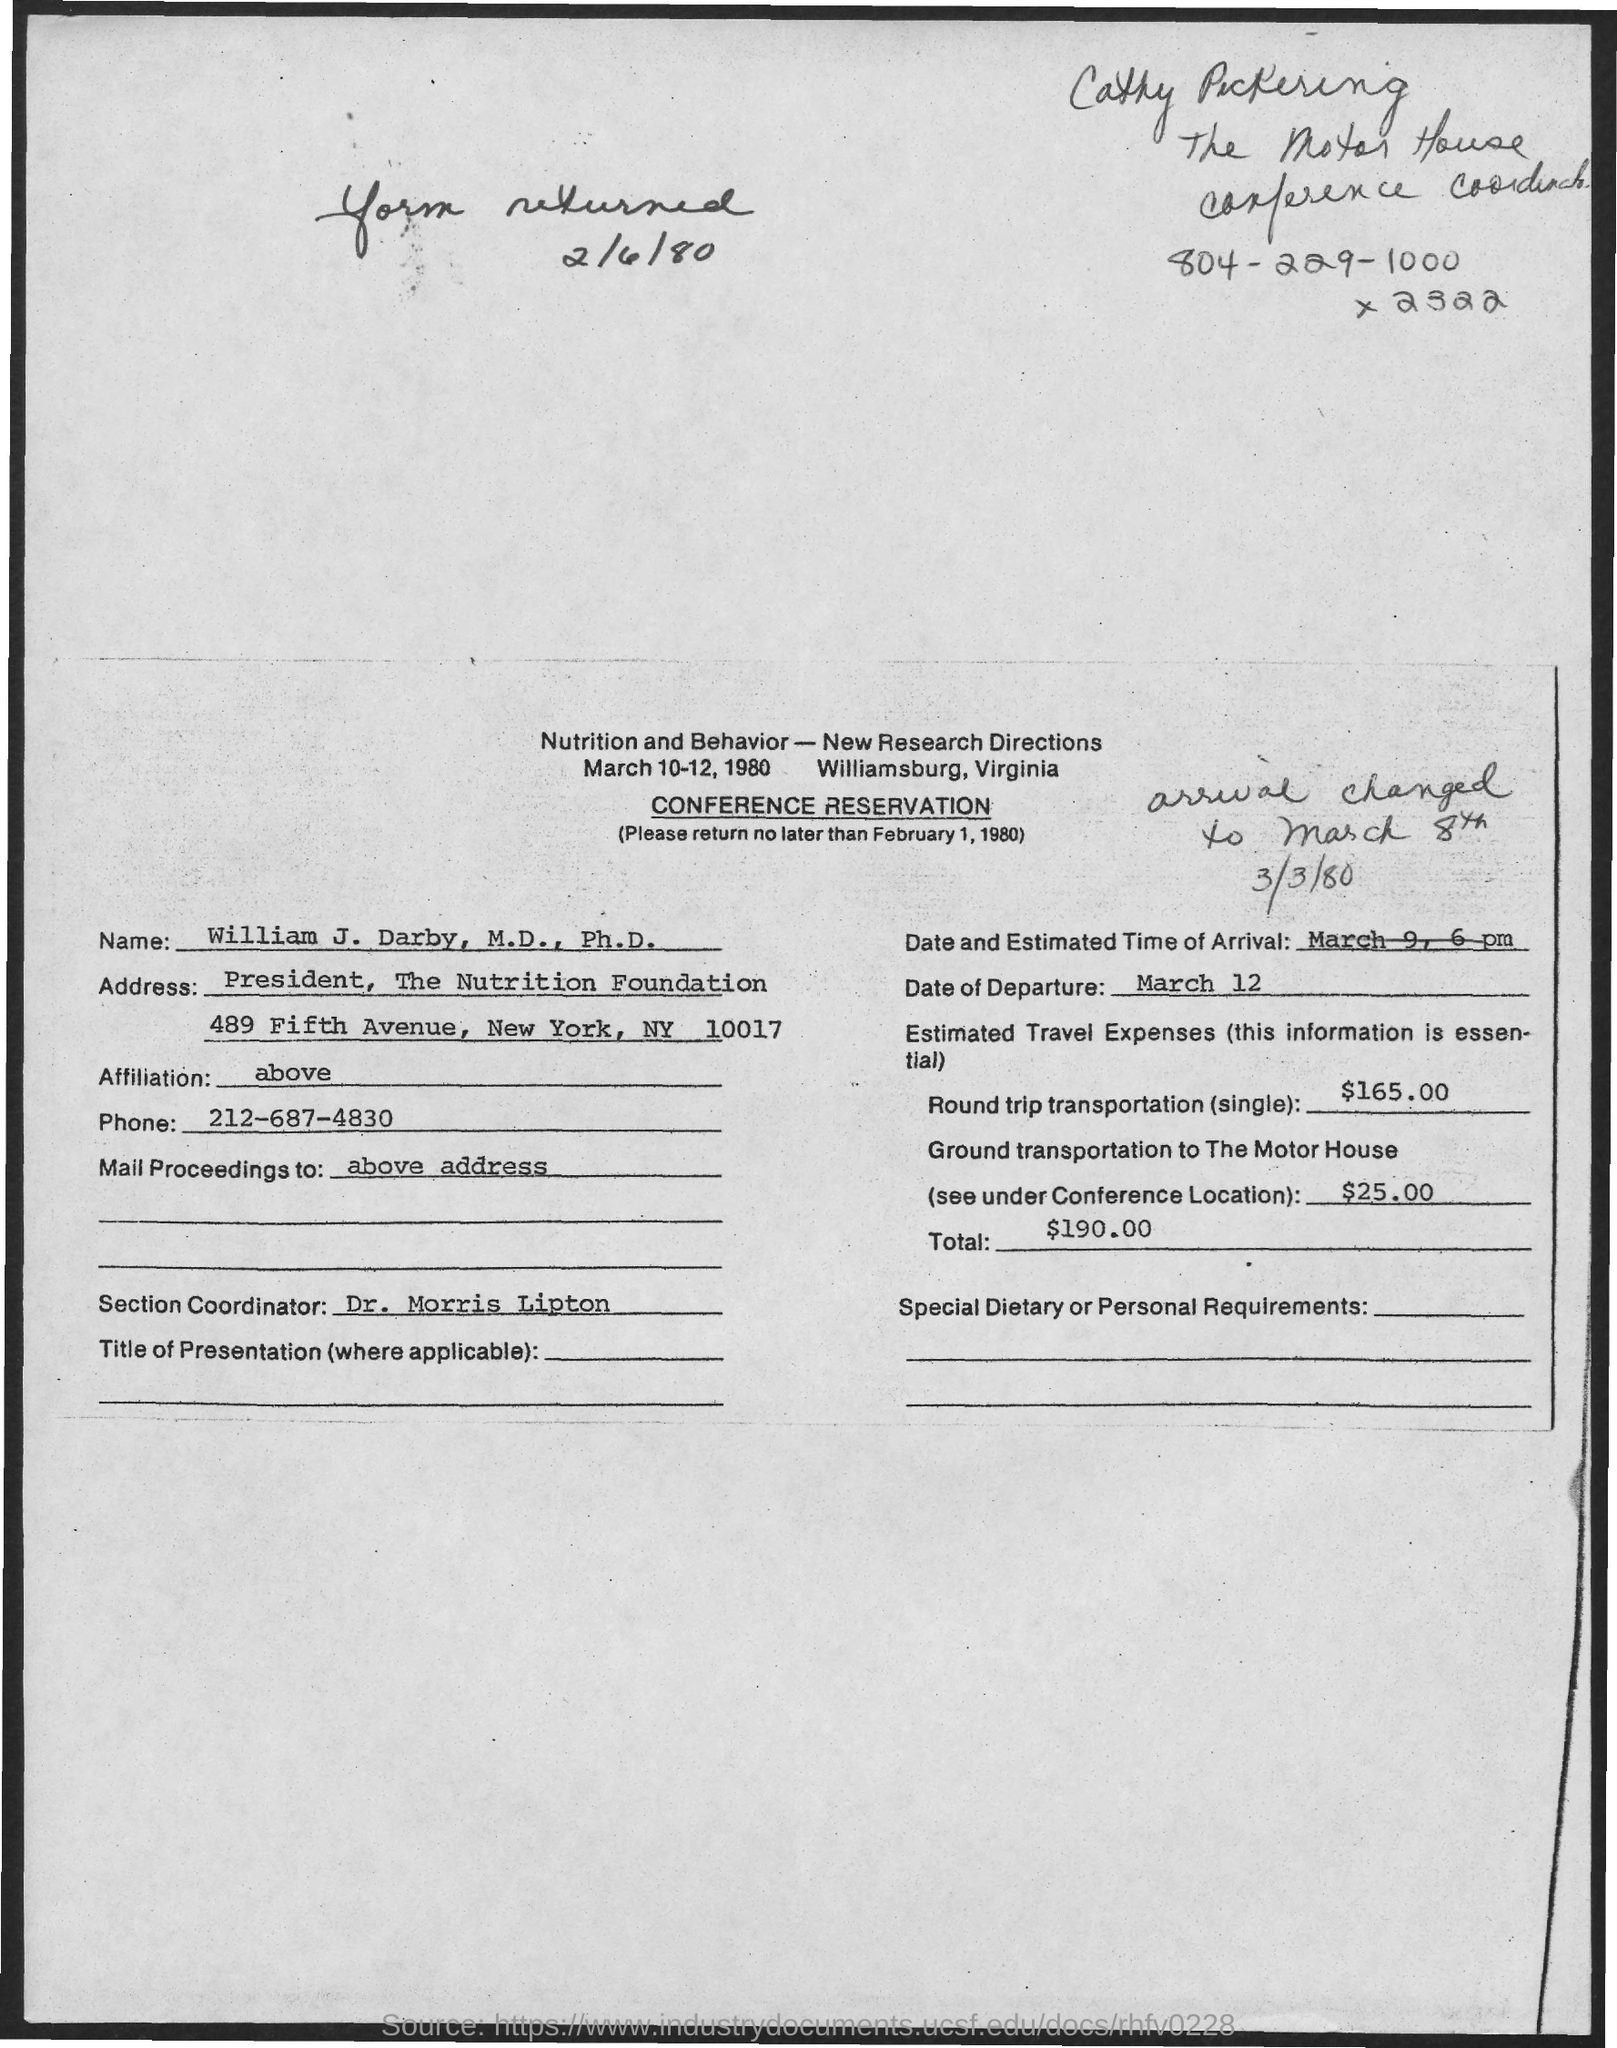When is the Form returned?
Your answer should be compact. 2/6/80. What date the form should be returned by?
Your answer should be compact. No later than February 1, 1980. What is the Name?
Make the answer very short. William J. Darby, M.D., Ph.D. What is the Phone?
Make the answer very short. 212-687-4830. What is the Estimated Travel expense for round trip transportation(single)?
Your answer should be very brief. $165.00. What is the Estimated Travel expense for Ground transpotation to The Motor House?
Make the answer very short. $25.00. What is the Total?
Give a very brief answer. $190.00. What is the Date of Depature?
Offer a very short reply. March 12. 